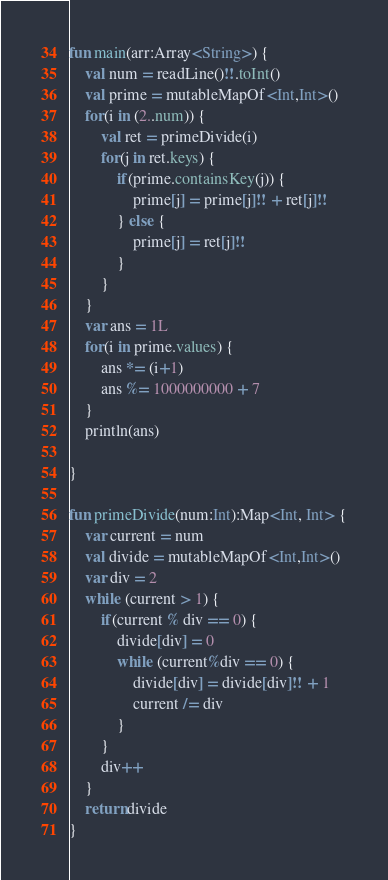<code> <loc_0><loc_0><loc_500><loc_500><_Kotlin_>fun main(arr:Array<String>) {
    val num = readLine()!!.toInt()
    val prime = mutableMapOf<Int,Int>()
    for(i in (2..num)) {
        val ret = primeDivide(i)
        for(j in ret.keys) {
            if(prime.containsKey(j)) {
                prime[j] = prime[j]!! + ret[j]!!
            } else {
                prime[j] = ret[j]!!
            }
        }
    }
    var ans = 1L
    for(i in prime.values) {
        ans *= (i+1)
        ans %= 1000000000 + 7
    }
    println(ans)

}

fun primeDivide(num:Int):Map<Int, Int> {
    var current = num
    val divide = mutableMapOf<Int,Int>()
    var div = 2
    while (current > 1) {
        if(current % div == 0) {
            divide[div] = 0
            while (current%div == 0) {
                divide[div] = divide[div]!! + 1
                current /= div
            }
        }
        div++
    }
    return divide
}
</code> 